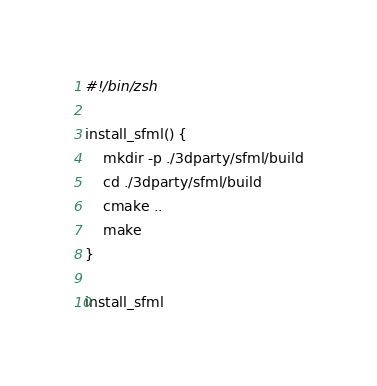<code> <loc_0><loc_0><loc_500><loc_500><_Bash_>#!/bin/zsh

install_sfml() {
    mkdir -p ./3dparty/sfml/build
    cd ./3dparty/sfml/build
    cmake ..
    make
}

install_sfml
</code> 